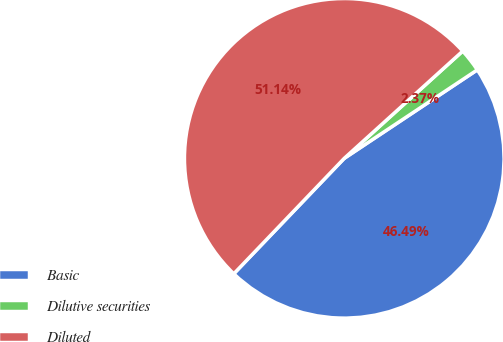<chart> <loc_0><loc_0><loc_500><loc_500><pie_chart><fcel>Basic<fcel>Dilutive securities<fcel>Diluted<nl><fcel>46.49%<fcel>2.37%<fcel>51.14%<nl></chart> 